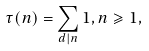<formula> <loc_0><loc_0><loc_500><loc_500>\tau ( n ) = \sum _ { d | n } 1 , n \geqslant 1 ,</formula> 